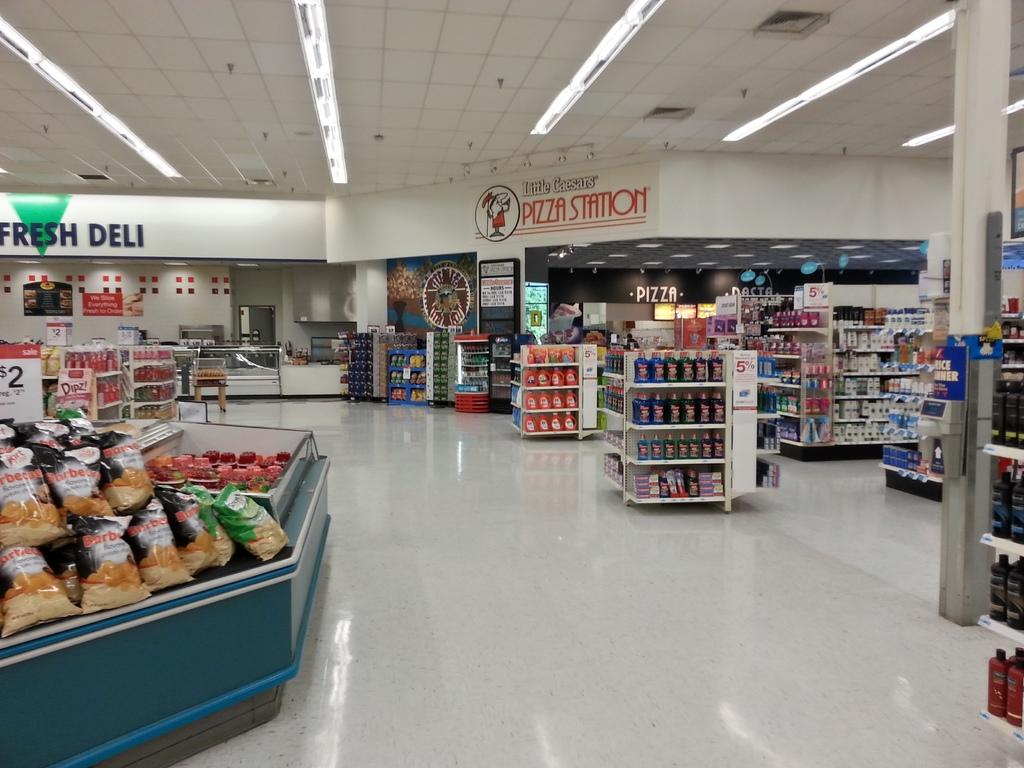What is does the red text near the top center of the image say?
Ensure brevity in your answer.  Pizza station. What section of the supermarket is on the left?
Provide a succinct answer. Fresh deli. 